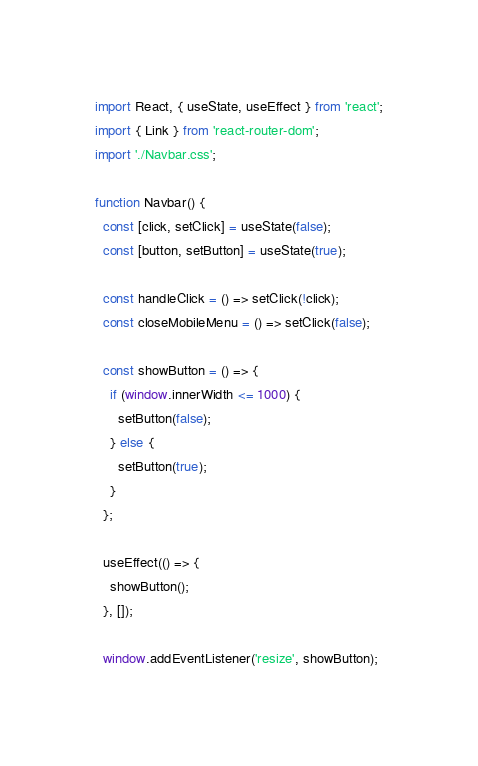<code> <loc_0><loc_0><loc_500><loc_500><_JavaScript_>import React, { useState, useEffect } from 'react';
import { Link } from 'react-router-dom';
import './Navbar.css';

function Navbar() {
  const [click, setClick] = useState(false);
  const [button, setButton] = useState(true);

  const handleClick = () => setClick(!click);
  const closeMobileMenu = () => setClick(false);

  const showButton = () => {
    if (window.innerWidth <= 1000) {
      setButton(false);
    } else {
      setButton(true);
    }
  };

  useEffect(() => {
    showButton();
  }, []);

  window.addEventListener('resize', showButton);
</code> 